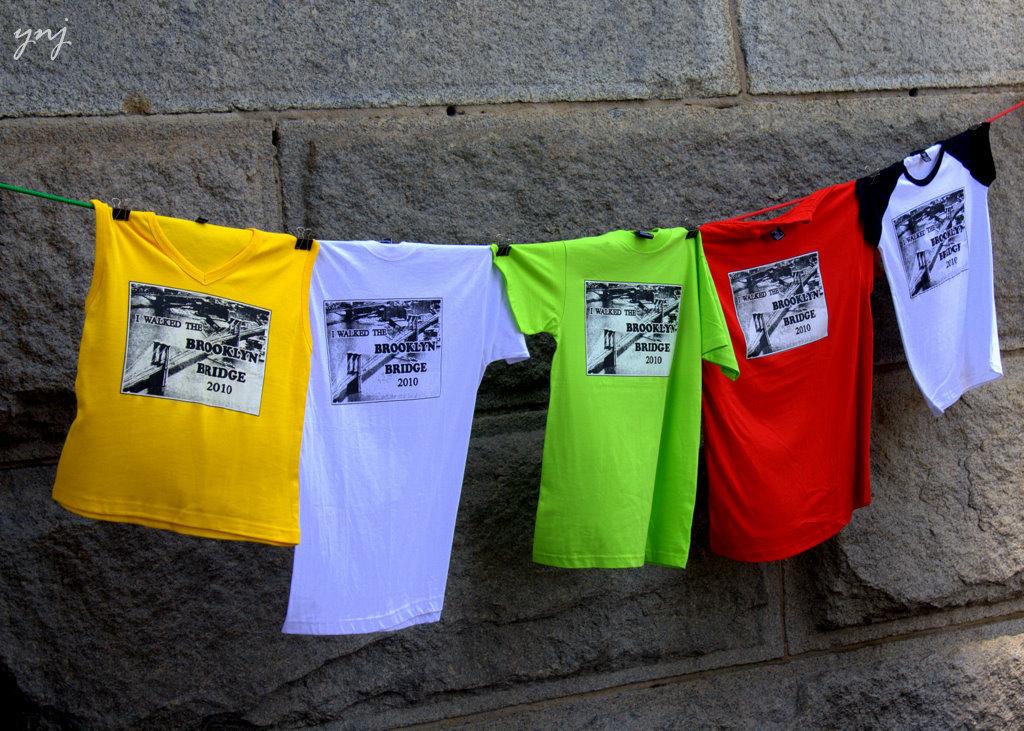What is that bridge called?
Offer a terse response. Brooklyn bridge. What year are these shirts for?
Offer a very short reply. 2010. 